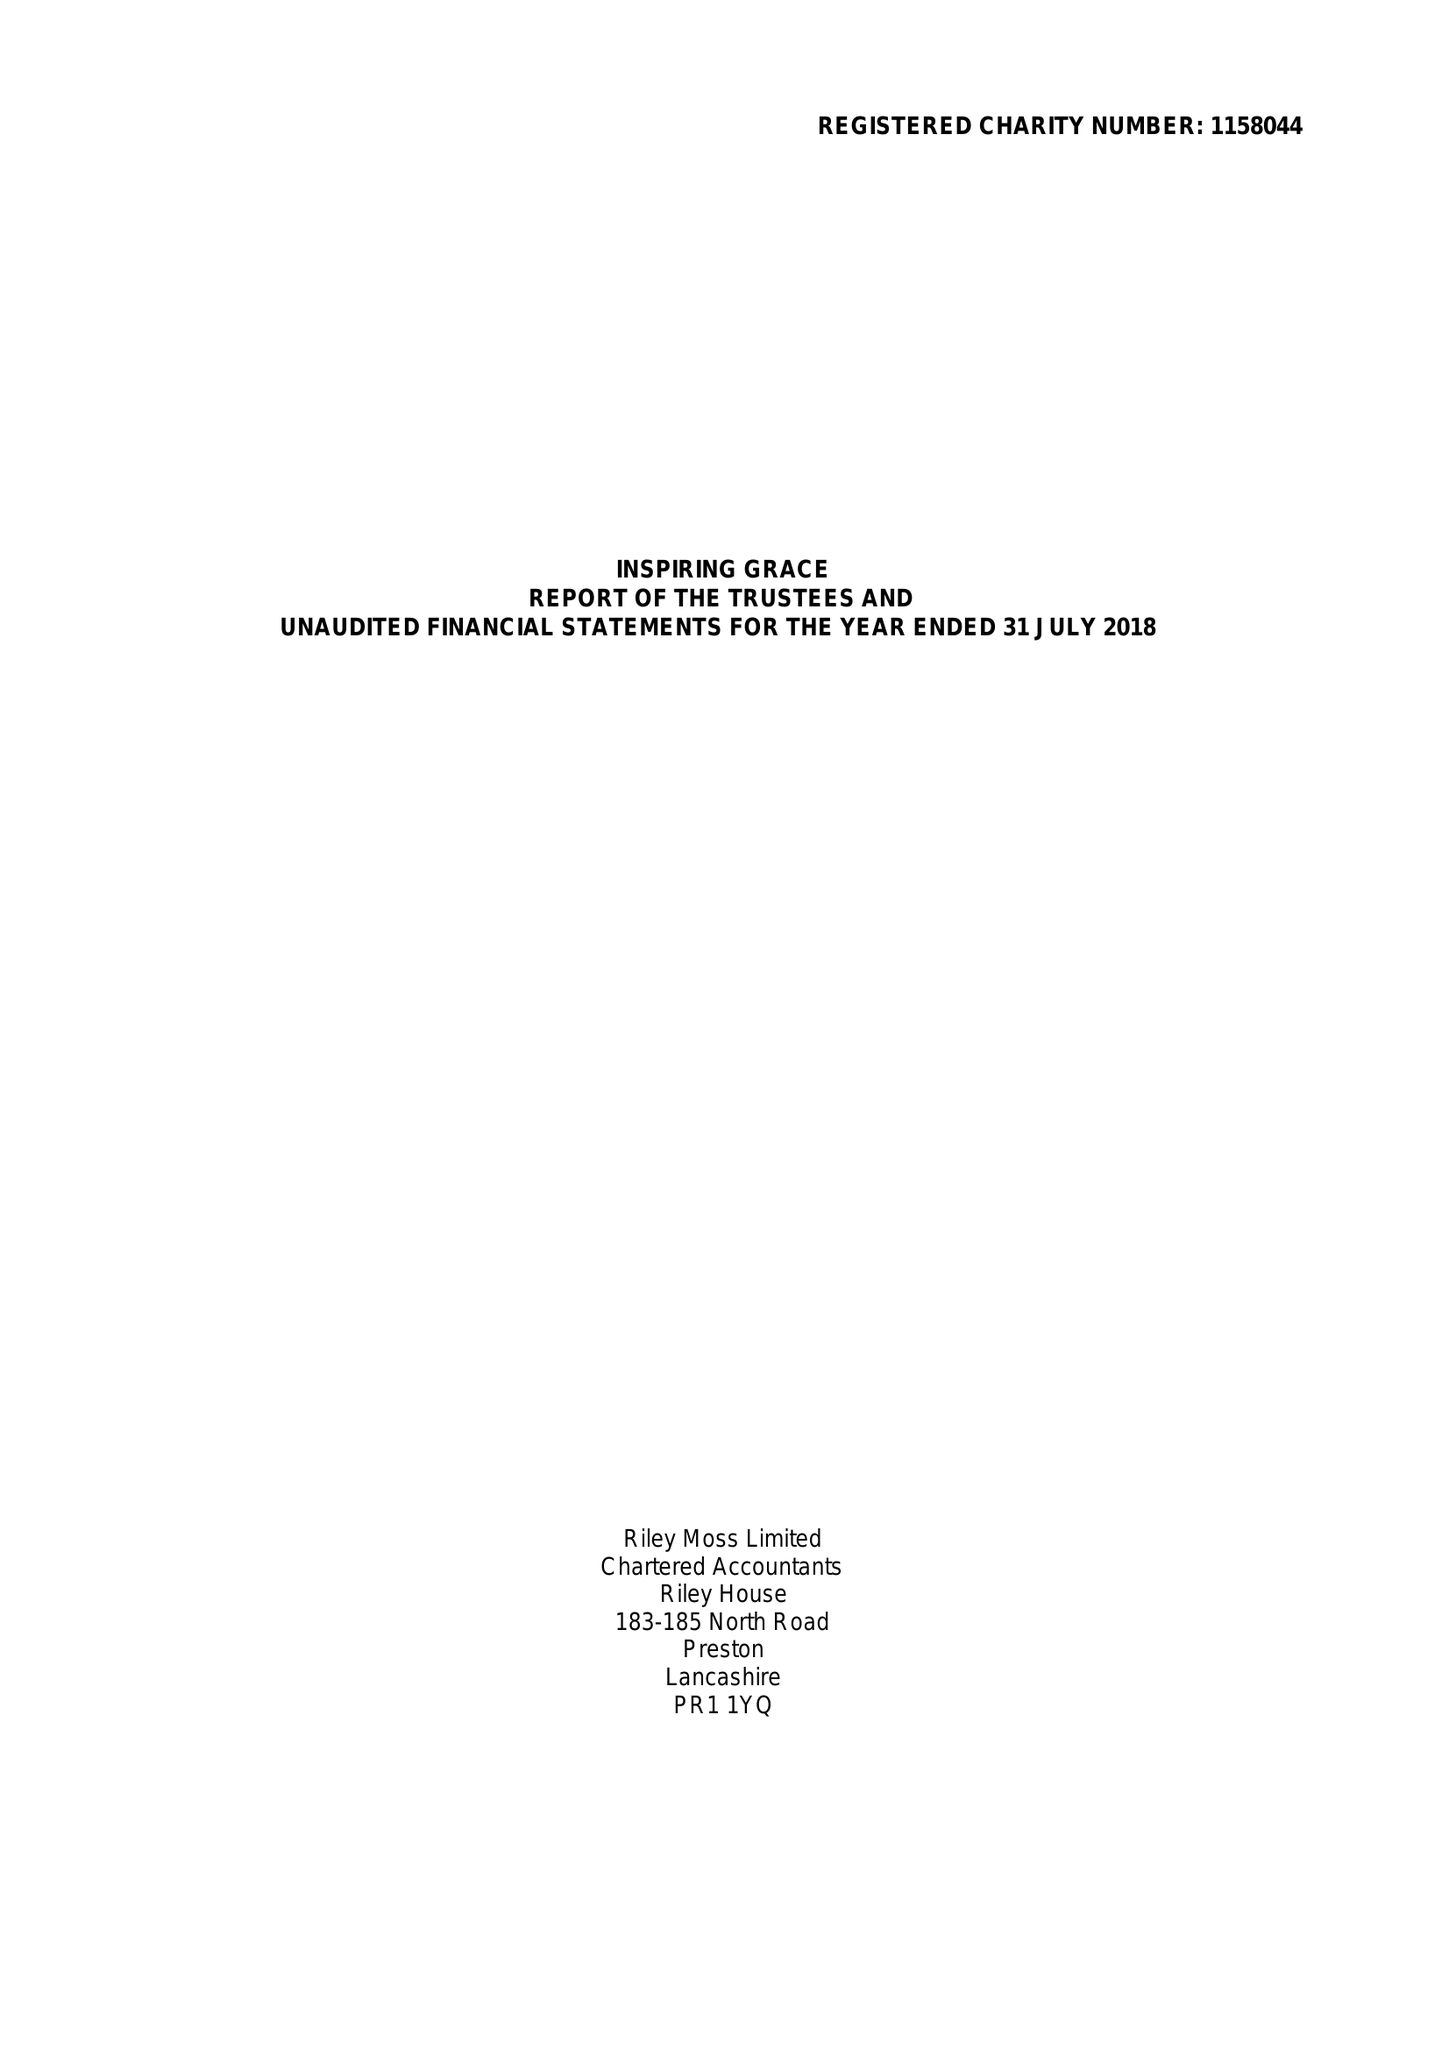What is the value for the report_date?
Answer the question using a single word or phrase. 2018-07-31 